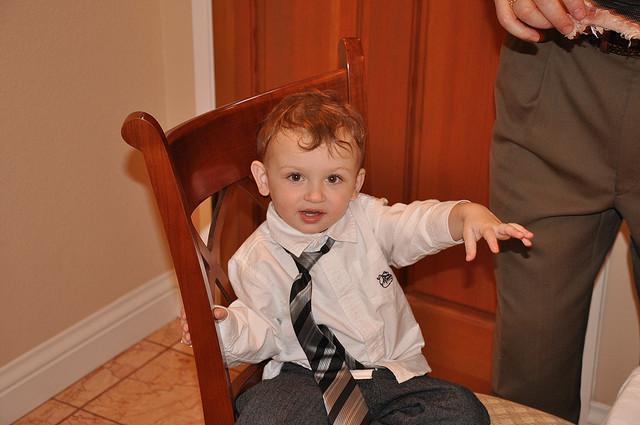What piece of clothing does the boy have on that are meant for adults?
Pick the right solution, then justify: 'Answer: answer
Rationale: rationale.'
Options: Belt, tie, his shirt, pants. Answer: tie.
Rationale: It is normally worn by adults. 